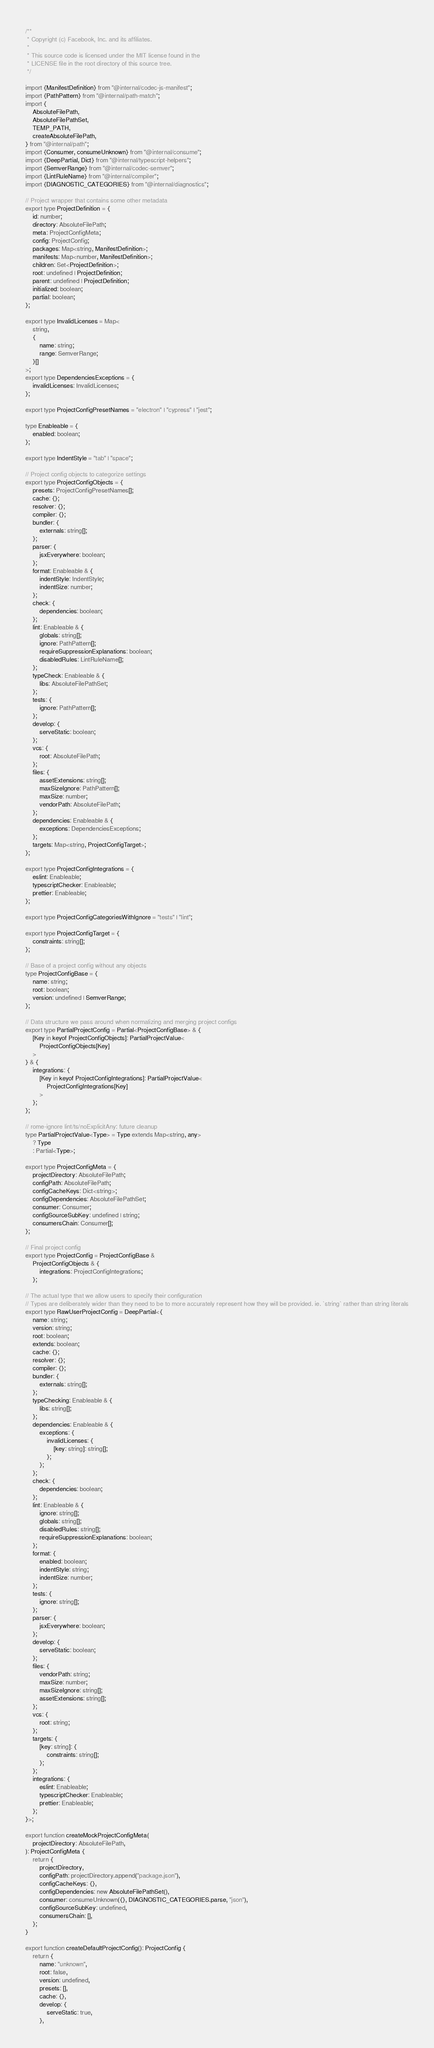<code> <loc_0><loc_0><loc_500><loc_500><_TypeScript_>/**
 * Copyright (c) Facebook, Inc. and its affiliates.
 *
 * This source code is licensed under the MIT license found in the
 * LICENSE file in the root directory of this source tree.
 */

import {ManifestDefinition} from "@internal/codec-js-manifest";
import {PathPattern} from "@internal/path-match";
import {
	AbsoluteFilePath,
	AbsoluteFilePathSet,
	TEMP_PATH,
	createAbsoluteFilePath,
} from "@internal/path";
import {Consumer, consumeUnknown} from "@internal/consume";
import {DeepPartial, Dict} from "@internal/typescript-helpers";
import {SemverRange} from "@internal/codec-semver";
import {LintRuleName} from "@internal/compiler";
import {DIAGNOSTIC_CATEGORIES} from "@internal/diagnostics";

// Project wrapper that contains some other metadata
export type ProjectDefinition = {
	id: number;
	directory: AbsoluteFilePath;
	meta: ProjectConfigMeta;
	config: ProjectConfig;
	packages: Map<string, ManifestDefinition>;
	manifests: Map<number, ManifestDefinition>;
	children: Set<ProjectDefinition>;
	root: undefined | ProjectDefinition;
	parent: undefined | ProjectDefinition;
	initialized: boolean;
	partial: boolean;
};

export type InvalidLicenses = Map<
	string,
	{
		name: string;
		range: SemverRange;
	}[]
>;
export type DependenciesExceptions = {
	invalidLicenses: InvalidLicenses;
};

export type ProjectConfigPresetNames = "electron" | "cypress" | "jest";

type Enableable = {
	enabled: boolean;
};

export type IndentStyle = "tab" | "space";

// Project config objects to categorize settings
export type ProjectConfigObjects = {
	presets: ProjectConfigPresetNames[];
	cache: {};
	resolver: {};
	compiler: {};
	bundler: {
		externals: string[];
	};
	parser: {
		jsxEverywhere: boolean;
	};
	format: Enableable & {
		indentStyle: IndentStyle;
		indentSize: number;
	};
	check: {
		dependencies: boolean;
	};
	lint: Enableable & {
		globals: string[];
		ignore: PathPattern[];
		requireSuppressionExplanations: boolean;
		disabledRules: LintRuleName[];
	};
	typeCheck: Enableable & {
		libs: AbsoluteFilePathSet;
	};
	tests: {
		ignore: PathPattern[];
	};
	develop: {
		serveStatic: boolean;
	};
	vcs: {
		root: AbsoluteFilePath;
	};
	files: {
		assetExtensions: string[];
		maxSizeIgnore: PathPattern[];
		maxSize: number;
		vendorPath: AbsoluteFilePath;
	};
	dependencies: Enableable & {
		exceptions: DependenciesExceptions;
	};
	targets: Map<string, ProjectConfigTarget>;
};

export type ProjectConfigIntegrations = {
	eslint: Enableable;
	typescriptChecker: Enableable;
	prettier: Enableable;
};

export type ProjectConfigCategoriesWithIgnore = "tests" | "lint";

export type ProjectConfigTarget = {
	constraints: string[];
};

// Base of a project config without any objects
type ProjectConfigBase = {
	name: string;
	root: boolean;
	version: undefined | SemverRange;
};

// Data structure we pass around when normalizing and merging project configs
export type PartialProjectConfig = Partial<ProjectConfigBase> & {
	[Key in keyof ProjectConfigObjects]: PartialProjectValue<
		ProjectConfigObjects[Key]
	>
} & {
	integrations: {
		[Key in keyof ProjectConfigIntegrations]: PartialProjectValue<
			ProjectConfigIntegrations[Key]
		>
	};
};

// rome-ignore lint/ts/noExplicitAny: future cleanup
type PartialProjectValue<Type> = Type extends Map<string, any>
	? Type
	: Partial<Type>;

export type ProjectConfigMeta = {
	projectDirectory: AbsoluteFilePath;
	configPath: AbsoluteFilePath;
	configCacheKeys: Dict<string>;
	configDependencies: AbsoluteFilePathSet;
	consumer: Consumer;
	configSourceSubKey: undefined | string;
	consumersChain: Consumer[];
};

// Final project config
export type ProjectConfig = ProjectConfigBase &
	ProjectConfigObjects & {
		integrations: ProjectConfigIntegrations;
	};

// The actual type that we allow users to specify their configuration
// Types are deliberately wider than they need to be to more accurately represent how they will be provided. ie. `string` rather than string literals
export type RawUserProjectConfig = DeepPartial<{
	name: string;
	version: string;
	root: boolean;
	extends: boolean;
	cache: {};
	resolver: {};
	compiler: {};
	bundler: {
		externals: string[];
	};
	typeChecking: Enableable & {
		libs: string[];
	};
	dependencies: Enableable & {
		exceptions: {
			invalidLicenses: {
				[key: string]: string[];
			};
		};
	};
	check: {
		dependencies: boolean;
	};
	lint: Enableable & {
		ignore: string[];
		globals: string[];
		disabledRules: string[];
		requireSuppressionExplanations: boolean;
	};
	format: {
		enabled: boolean;
		indentStyle: string;
		indentSize: number;
	};
	tests: {
		ignore: string[];
	};
	parser: {
		jsxEverywhere: boolean;
	};
	develop: {
		serveStatic: boolean;
	};
	files: {
		vendorPath: string;
		maxSize: number;
		maxSizeIgnore: string[];
		assetExtensions: string[];
	};
	vcs: {
		root: string;
	};
	targets: {
		[key: string]: {
			constraints: string[];
		};
	};
	integrations: {
		eslint: Enableable;
		typescriptChecker: Enableable;
		prettier: Enableable;
	};
}>;

export function createMockProjectConfigMeta(
	projectDirectory: AbsoluteFilePath,
): ProjectConfigMeta {
	return {
		projectDirectory,
		configPath: projectDirectory.append("package.json"),
		configCacheKeys: {},
		configDependencies: new AbsoluteFilePathSet(),
		consumer: consumeUnknown({}, DIAGNOSTIC_CATEGORIES.parse, "json"),
		configSourceSubKey: undefined,
		consumersChain: [],
	};
}

export function createDefaultProjectConfig(): ProjectConfig {
	return {
		name: "unknown",
		root: false,
		version: undefined,
		presets: [],
		cache: {},
		develop: {
			serveStatic: true,
		},</code> 